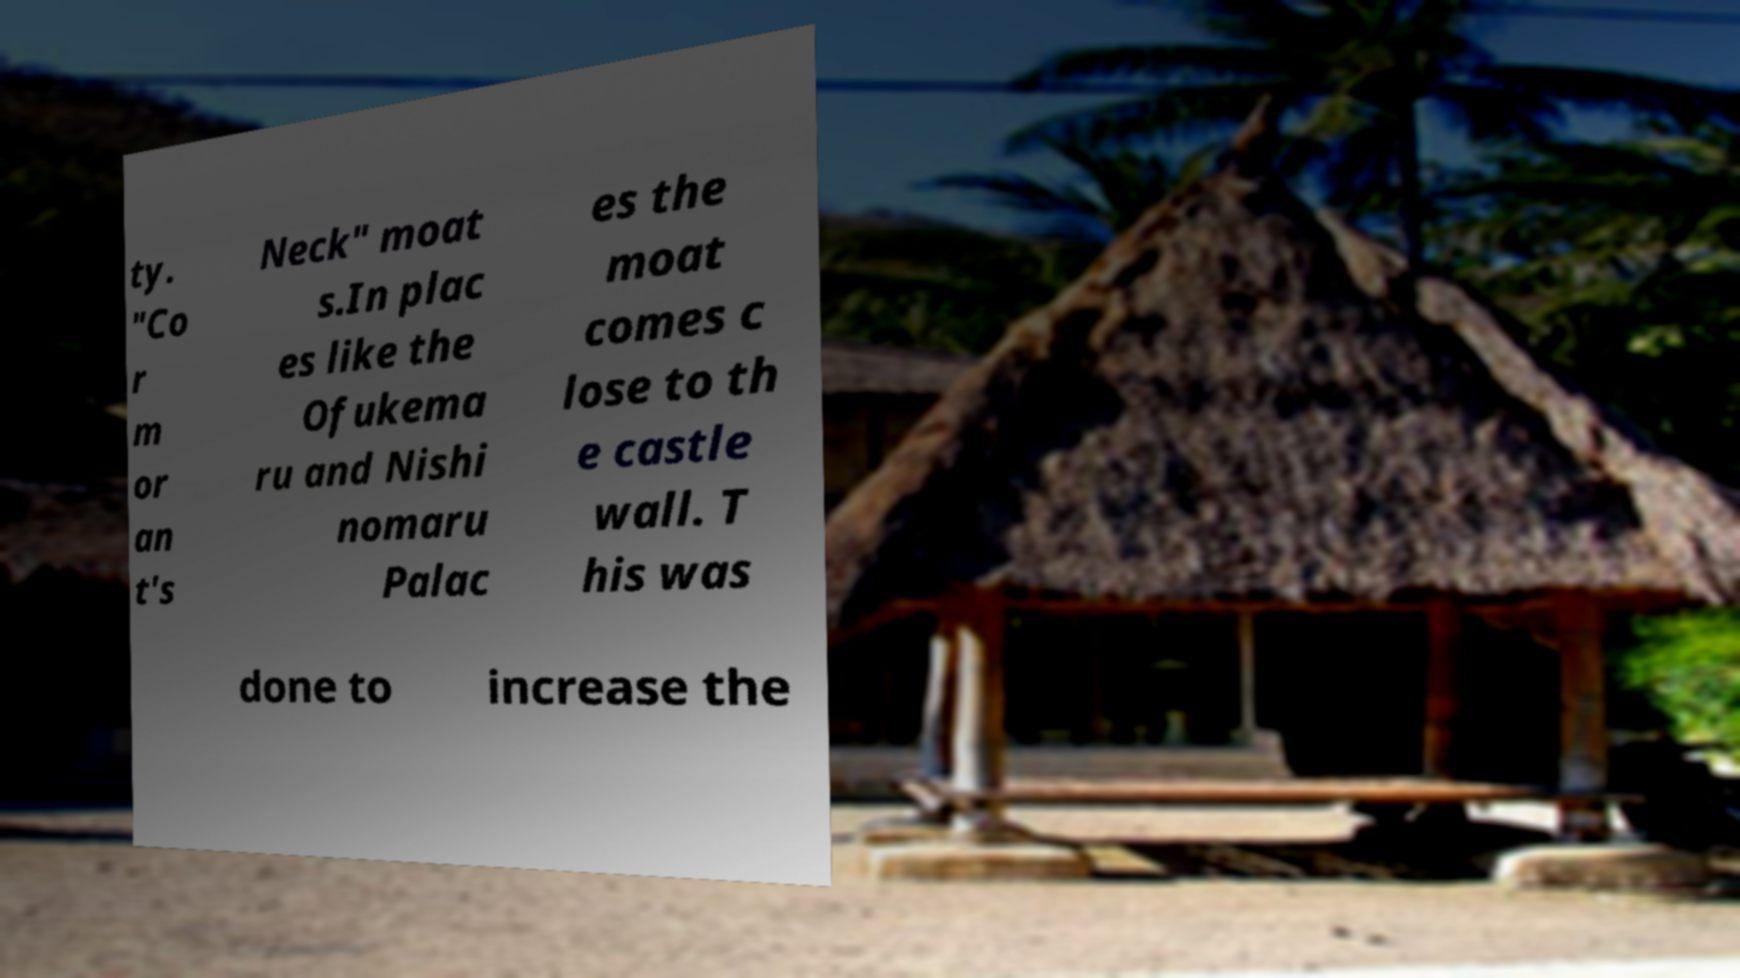Can you read and provide the text displayed in the image?This photo seems to have some interesting text. Can you extract and type it out for me? ty. "Co r m or an t's Neck" moat s.In plac es like the Ofukema ru and Nishi nomaru Palac es the moat comes c lose to th e castle wall. T his was done to increase the 